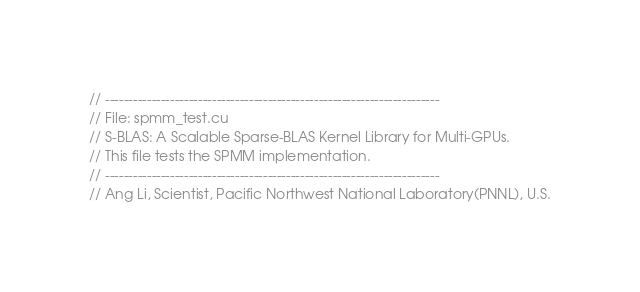Convert code to text. <code><loc_0><loc_0><loc_500><loc_500><_Cuda_>// ------------------------------------------------------------------------
// File: spmm_test.cu
// S-BLAS: A Scalable Sparse-BLAS Kernel Library for Multi-GPUs.
// This file tests the SPMM implementation.
// ------------------------------------------------------------------------
// Ang Li, Scientist, Pacific Northwest National Laboratory(PNNL), U.S.</code> 